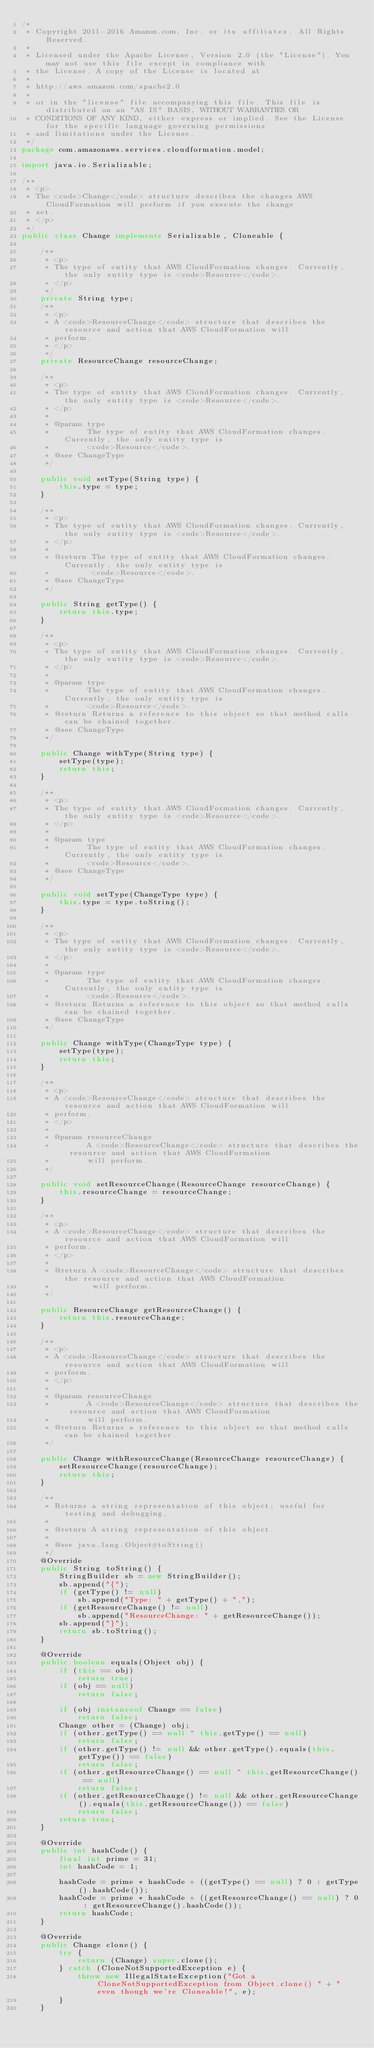Convert code to text. <code><loc_0><loc_0><loc_500><loc_500><_Java_>/*
 * Copyright 2011-2016 Amazon.com, Inc. or its affiliates. All Rights Reserved.
 * 
 * Licensed under the Apache License, Version 2.0 (the "License"). You may not use this file except in compliance with
 * the License. A copy of the License is located at
 * 
 * http://aws.amazon.com/apache2.0
 * 
 * or in the "license" file accompanying this file. This file is distributed on an "AS IS" BASIS, WITHOUT WARRANTIES OR
 * CONDITIONS OF ANY KIND, either express or implied. See the License for the specific language governing permissions
 * and limitations under the License.
 */
package com.amazonaws.services.cloudformation.model;

import java.io.Serializable;

/**
 * <p>
 * The <code>Change</code> structure describes the changes AWS CloudFormation will perform if you execute the change
 * set.
 * </p>
 */
public class Change implements Serializable, Cloneable {

    /**
     * <p>
     * The type of entity that AWS CloudFormation changes. Currently, the only entity type is <code>Resource</code>.
     * </p>
     */
    private String type;
    /**
     * <p>
     * A <code>ResourceChange</code> structure that describes the resource and action that AWS CloudFormation will
     * perform.
     * </p>
     */
    private ResourceChange resourceChange;

    /**
     * <p>
     * The type of entity that AWS CloudFormation changes. Currently, the only entity type is <code>Resource</code>.
     * </p>
     * 
     * @param type
     *        The type of entity that AWS CloudFormation changes. Currently, the only entity type is
     *        <code>Resource</code>.
     * @see ChangeType
     */

    public void setType(String type) {
        this.type = type;
    }

    /**
     * <p>
     * The type of entity that AWS CloudFormation changes. Currently, the only entity type is <code>Resource</code>.
     * </p>
     * 
     * @return The type of entity that AWS CloudFormation changes. Currently, the only entity type is
     *         <code>Resource</code>.
     * @see ChangeType
     */

    public String getType() {
        return this.type;
    }

    /**
     * <p>
     * The type of entity that AWS CloudFormation changes. Currently, the only entity type is <code>Resource</code>.
     * </p>
     * 
     * @param type
     *        The type of entity that AWS CloudFormation changes. Currently, the only entity type is
     *        <code>Resource</code>.
     * @return Returns a reference to this object so that method calls can be chained together.
     * @see ChangeType
     */

    public Change withType(String type) {
        setType(type);
        return this;
    }

    /**
     * <p>
     * The type of entity that AWS CloudFormation changes. Currently, the only entity type is <code>Resource</code>.
     * </p>
     * 
     * @param type
     *        The type of entity that AWS CloudFormation changes. Currently, the only entity type is
     *        <code>Resource</code>.
     * @see ChangeType
     */

    public void setType(ChangeType type) {
        this.type = type.toString();
    }

    /**
     * <p>
     * The type of entity that AWS CloudFormation changes. Currently, the only entity type is <code>Resource</code>.
     * </p>
     * 
     * @param type
     *        The type of entity that AWS CloudFormation changes. Currently, the only entity type is
     *        <code>Resource</code>.
     * @return Returns a reference to this object so that method calls can be chained together.
     * @see ChangeType
     */

    public Change withType(ChangeType type) {
        setType(type);
        return this;
    }

    /**
     * <p>
     * A <code>ResourceChange</code> structure that describes the resource and action that AWS CloudFormation will
     * perform.
     * </p>
     * 
     * @param resourceChange
     *        A <code>ResourceChange</code> structure that describes the resource and action that AWS CloudFormation
     *        will perform.
     */

    public void setResourceChange(ResourceChange resourceChange) {
        this.resourceChange = resourceChange;
    }

    /**
     * <p>
     * A <code>ResourceChange</code> structure that describes the resource and action that AWS CloudFormation will
     * perform.
     * </p>
     * 
     * @return A <code>ResourceChange</code> structure that describes the resource and action that AWS CloudFormation
     *         will perform.
     */

    public ResourceChange getResourceChange() {
        return this.resourceChange;
    }

    /**
     * <p>
     * A <code>ResourceChange</code> structure that describes the resource and action that AWS CloudFormation will
     * perform.
     * </p>
     * 
     * @param resourceChange
     *        A <code>ResourceChange</code> structure that describes the resource and action that AWS CloudFormation
     *        will perform.
     * @return Returns a reference to this object so that method calls can be chained together.
     */

    public Change withResourceChange(ResourceChange resourceChange) {
        setResourceChange(resourceChange);
        return this;
    }

    /**
     * Returns a string representation of this object; useful for testing and debugging.
     *
     * @return A string representation of this object.
     *
     * @see java.lang.Object#toString()
     */
    @Override
    public String toString() {
        StringBuilder sb = new StringBuilder();
        sb.append("{");
        if (getType() != null)
            sb.append("Type: " + getType() + ",");
        if (getResourceChange() != null)
            sb.append("ResourceChange: " + getResourceChange());
        sb.append("}");
        return sb.toString();
    }

    @Override
    public boolean equals(Object obj) {
        if (this == obj)
            return true;
        if (obj == null)
            return false;

        if (obj instanceof Change == false)
            return false;
        Change other = (Change) obj;
        if (other.getType() == null ^ this.getType() == null)
            return false;
        if (other.getType() != null && other.getType().equals(this.getType()) == false)
            return false;
        if (other.getResourceChange() == null ^ this.getResourceChange() == null)
            return false;
        if (other.getResourceChange() != null && other.getResourceChange().equals(this.getResourceChange()) == false)
            return false;
        return true;
    }

    @Override
    public int hashCode() {
        final int prime = 31;
        int hashCode = 1;

        hashCode = prime * hashCode + ((getType() == null) ? 0 : getType().hashCode());
        hashCode = prime * hashCode + ((getResourceChange() == null) ? 0 : getResourceChange().hashCode());
        return hashCode;
    }

    @Override
    public Change clone() {
        try {
            return (Change) super.clone();
        } catch (CloneNotSupportedException e) {
            throw new IllegalStateException("Got a CloneNotSupportedException from Object.clone() " + "even though we're Cloneable!", e);
        }
    }</code> 